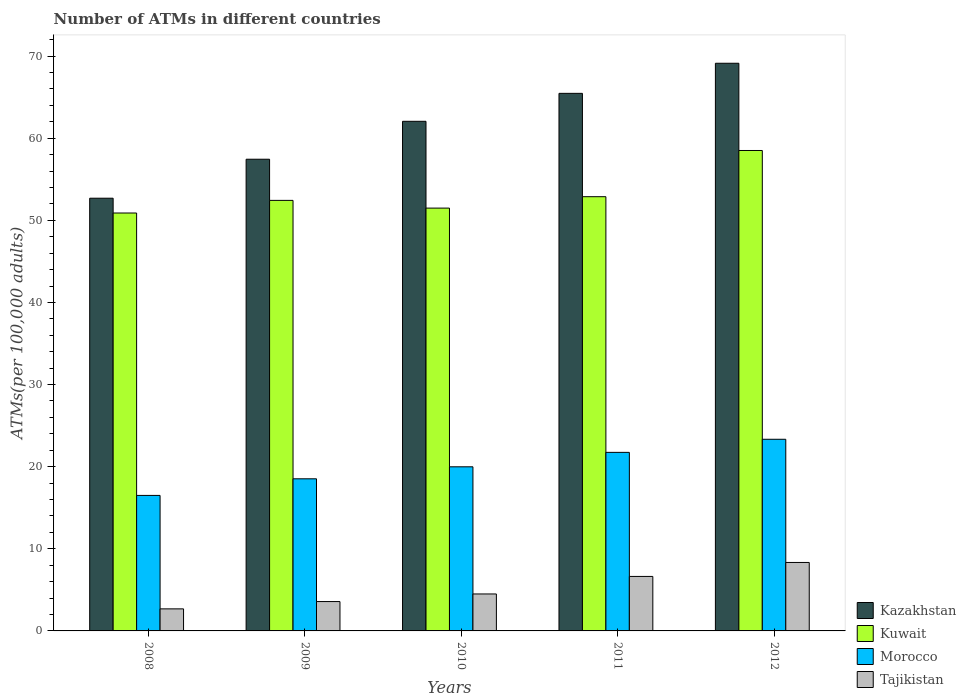How many different coloured bars are there?
Make the answer very short. 4. How many groups of bars are there?
Make the answer very short. 5. Are the number of bars on each tick of the X-axis equal?
Your answer should be very brief. Yes. How many bars are there on the 3rd tick from the left?
Your response must be concise. 4. How many bars are there on the 4th tick from the right?
Your response must be concise. 4. What is the label of the 4th group of bars from the left?
Your response must be concise. 2011. What is the number of ATMs in Kuwait in 2008?
Provide a short and direct response. 50.89. Across all years, what is the maximum number of ATMs in Kazakhstan?
Your response must be concise. 69.12. Across all years, what is the minimum number of ATMs in Tajikistan?
Your answer should be compact. 2.69. In which year was the number of ATMs in Kuwait maximum?
Offer a terse response. 2012. In which year was the number of ATMs in Morocco minimum?
Your answer should be very brief. 2008. What is the total number of ATMs in Morocco in the graph?
Ensure brevity in your answer.  100.09. What is the difference between the number of ATMs in Kuwait in 2008 and that in 2010?
Give a very brief answer. -0.6. What is the difference between the number of ATMs in Kazakhstan in 2011 and the number of ATMs in Kuwait in 2012?
Your response must be concise. 6.96. What is the average number of ATMs in Kazakhstan per year?
Keep it short and to the point. 61.35. In the year 2012, what is the difference between the number of ATMs in Kazakhstan and number of ATMs in Tajikistan?
Your answer should be very brief. 60.79. In how many years, is the number of ATMs in Tajikistan greater than 60?
Your answer should be compact. 0. What is the ratio of the number of ATMs in Kuwait in 2008 to that in 2011?
Make the answer very short. 0.96. Is the difference between the number of ATMs in Kazakhstan in 2009 and 2011 greater than the difference between the number of ATMs in Tajikistan in 2009 and 2011?
Provide a short and direct response. No. What is the difference between the highest and the second highest number of ATMs in Kuwait?
Ensure brevity in your answer.  5.63. What is the difference between the highest and the lowest number of ATMs in Morocco?
Your answer should be very brief. 6.84. Is the sum of the number of ATMs in Kazakhstan in 2008 and 2012 greater than the maximum number of ATMs in Morocco across all years?
Provide a short and direct response. Yes. Is it the case that in every year, the sum of the number of ATMs in Tajikistan and number of ATMs in Morocco is greater than the sum of number of ATMs in Kuwait and number of ATMs in Kazakhstan?
Your response must be concise. Yes. What does the 1st bar from the left in 2011 represents?
Your answer should be compact. Kazakhstan. What does the 2nd bar from the right in 2010 represents?
Make the answer very short. Morocco. How many bars are there?
Provide a short and direct response. 20. Does the graph contain any zero values?
Provide a succinct answer. No. Does the graph contain grids?
Keep it short and to the point. No. What is the title of the graph?
Keep it short and to the point. Number of ATMs in different countries. Does "Guinea" appear as one of the legend labels in the graph?
Provide a succinct answer. No. What is the label or title of the Y-axis?
Keep it short and to the point. ATMs(per 100,0 adults). What is the ATMs(per 100,000 adults) of Kazakhstan in 2008?
Make the answer very short. 52.69. What is the ATMs(per 100,000 adults) in Kuwait in 2008?
Your answer should be very brief. 50.89. What is the ATMs(per 100,000 adults) of Morocco in 2008?
Your answer should be very brief. 16.5. What is the ATMs(per 100,000 adults) in Tajikistan in 2008?
Give a very brief answer. 2.69. What is the ATMs(per 100,000 adults) in Kazakhstan in 2009?
Give a very brief answer. 57.44. What is the ATMs(per 100,000 adults) in Kuwait in 2009?
Your answer should be compact. 52.43. What is the ATMs(per 100,000 adults) of Morocco in 2009?
Offer a very short reply. 18.52. What is the ATMs(per 100,000 adults) in Tajikistan in 2009?
Your response must be concise. 3.58. What is the ATMs(per 100,000 adults) in Kazakhstan in 2010?
Make the answer very short. 62.05. What is the ATMs(per 100,000 adults) in Kuwait in 2010?
Your response must be concise. 51.49. What is the ATMs(per 100,000 adults) in Morocco in 2010?
Make the answer very short. 19.98. What is the ATMs(per 100,000 adults) in Tajikistan in 2010?
Keep it short and to the point. 4.5. What is the ATMs(per 100,000 adults) in Kazakhstan in 2011?
Provide a succinct answer. 65.46. What is the ATMs(per 100,000 adults) in Kuwait in 2011?
Make the answer very short. 52.87. What is the ATMs(per 100,000 adults) in Morocco in 2011?
Your answer should be compact. 21.74. What is the ATMs(per 100,000 adults) of Tajikistan in 2011?
Provide a short and direct response. 6.64. What is the ATMs(per 100,000 adults) in Kazakhstan in 2012?
Your response must be concise. 69.12. What is the ATMs(per 100,000 adults) of Kuwait in 2012?
Make the answer very short. 58.5. What is the ATMs(per 100,000 adults) of Morocco in 2012?
Your answer should be compact. 23.34. What is the ATMs(per 100,000 adults) in Tajikistan in 2012?
Provide a succinct answer. 8.34. Across all years, what is the maximum ATMs(per 100,000 adults) of Kazakhstan?
Provide a short and direct response. 69.12. Across all years, what is the maximum ATMs(per 100,000 adults) of Kuwait?
Provide a succinct answer. 58.5. Across all years, what is the maximum ATMs(per 100,000 adults) in Morocco?
Keep it short and to the point. 23.34. Across all years, what is the maximum ATMs(per 100,000 adults) of Tajikistan?
Keep it short and to the point. 8.34. Across all years, what is the minimum ATMs(per 100,000 adults) in Kazakhstan?
Provide a succinct answer. 52.69. Across all years, what is the minimum ATMs(per 100,000 adults) in Kuwait?
Your answer should be very brief. 50.89. Across all years, what is the minimum ATMs(per 100,000 adults) in Morocco?
Your answer should be compact. 16.5. Across all years, what is the minimum ATMs(per 100,000 adults) in Tajikistan?
Ensure brevity in your answer.  2.69. What is the total ATMs(per 100,000 adults) in Kazakhstan in the graph?
Give a very brief answer. 306.76. What is the total ATMs(per 100,000 adults) in Kuwait in the graph?
Make the answer very short. 266.18. What is the total ATMs(per 100,000 adults) in Morocco in the graph?
Offer a terse response. 100.09. What is the total ATMs(per 100,000 adults) of Tajikistan in the graph?
Give a very brief answer. 25.73. What is the difference between the ATMs(per 100,000 adults) of Kazakhstan in 2008 and that in 2009?
Make the answer very short. -4.75. What is the difference between the ATMs(per 100,000 adults) in Kuwait in 2008 and that in 2009?
Offer a terse response. -1.54. What is the difference between the ATMs(per 100,000 adults) of Morocco in 2008 and that in 2009?
Your answer should be compact. -2.02. What is the difference between the ATMs(per 100,000 adults) in Tajikistan in 2008 and that in 2009?
Provide a short and direct response. -0.89. What is the difference between the ATMs(per 100,000 adults) in Kazakhstan in 2008 and that in 2010?
Ensure brevity in your answer.  -9.36. What is the difference between the ATMs(per 100,000 adults) in Kuwait in 2008 and that in 2010?
Ensure brevity in your answer.  -0.6. What is the difference between the ATMs(per 100,000 adults) in Morocco in 2008 and that in 2010?
Provide a succinct answer. -3.48. What is the difference between the ATMs(per 100,000 adults) in Tajikistan in 2008 and that in 2010?
Make the answer very short. -1.82. What is the difference between the ATMs(per 100,000 adults) in Kazakhstan in 2008 and that in 2011?
Your response must be concise. -12.77. What is the difference between the ATMs(per 100,000 adults) of Kuwait in 2008 and that in 2011?
Offer a very short reply. -1.99. What is the difference between the ATMs(per 100,000 adults) of Morocco in 2008 and that in 2011?
Give a very brief answer. -5.24. What is the difference between the ATMs(per 100,000 adults) in Tajikistan in 2008 and that in 2011?
Ensure brevity in your answer.  -3.95. What is the difference between the ATMs(per 100,000 adults) of Kazakhstan in 2008 and that in 2012?
Ensure brevity in your answer.  -16.43. What is the difference between the ATMs(per 100,000 adults) of Kuwait in 2008 and that in 2012?
Offer a very short reply. -7.61. What is the difference between the ATMs(per 100,000 adults) of Morocco in 2008 and that in 2012?
Your answer should be very brief. -6.84. What is the difference between the ATMs(per 100,000 adults) of Tajikistan in 2008 and that in 2012?
Your answer should be very brief. -5.65. What is the difference between the ATMs(per 100,000 adults) of Kazakhstan in 2009 and that in 2010?
Offer a very short reply. -4.62. What is the difference between the ATMs(per 100,000 adults) in Kuwait in 2009 and that in 2010?
Ensure brevity in your answer.  0.94. What is the difference between the ATMs(per 100,000 adults) of Morocco in 2009 and that in 2010?
Provide a succinct answer. -1.46. What is the difference between the ATMs(per 100,000 adults) in Tajikistan in 2009 and that in 2010?
Give a very brief answer. -0.93. What is the difference between the ATMs(per 100,000 adults) of Kazakhstan in 2009 and that in 2011?
Your response must be concise. -8.02. What is the difference between the ATMs(per 100,000 adults) of Kuwait in 2009 and that in 2011?
Provide a succinct answer. -0.45. What is the difference between the ATMs(per 100,000 adults) of Morocco in 2009 and that in 2011?
Your answer should be very brief. -3.22. What is the difference between the ATMs(per 100,000 adults) of Tajikistan in 2009 and that in 2011?
Your answer should be very brief. -3.06. What is the difference between the ATMs(per 100,000 adults) of Kazakhstan in 2009 and that in 2012?
Offer a terse response. -11.69. What is the difference between the ATMs(per 100,000 adults) of Kuwait in 2009 and that in 2012?
Ensure brevity in your answer.  -6.07. What is the difference between the ATMs(per 100,000 adults) in Morocco in 2009 and that in 2012?
Keep it short and to the point. -4.81. What is the difference between the ATMs(per 100,000 adults) of Tajikistan in 2009 and that in 2012?
Your answer should be very brief. -4.76. What is the difference between the ATMs(per 100,000 adults) in Kazakhstan in 2010 and that in 2011?
Your answer should be compact. -3.4. What is the difference between the ATMs(per 100,000 adults) in Kuwait in 2010 and that in 2011?
Keep it short and to the point. -1.39. What is the difference between the ATMs(per 100,000 adults) of Morocco in 2010 and that in 2011?
Provide a short and direct response. -1.76. What is the difference between the ATMs(per 100,000 adults) in Tajikistan in 2010 and that in 2011?
Offer a very short reply. -2.13. What is the difference between the ATMs(per 100,000 adults) in Kazakhstan in 2010 and that in 2012?
Offer a terse response. -7.07. What is the difference between the ATMs(per 100,000 adults) in Kuwait in 2010 and that in 2012?
Ensure brevity in your answer.  -7.01. What is the difference between the ATMs(per 100,000 adults) in Morocco in 2010 and that in 2012?
Ensure brevity in your answer.  -3.35. What is the difference between the ATMs(per 100,000 adults) of Tajikistan in 2010 and that in 2012?
Give a very brief answer. -3.84. What is the difference between the ATMs(per 100,000 adults) in Kazakhstan in 2011 and that in 2012?
Offer a terse response. -3.66. What is the difference between the ATMs(per 100,000 adults) in Kuwait in 2011 and that in 2012?
Provide a short and direct response. -5.63. What is the difference between the ATMs(per 100,000 adults) in Morocco in 2011 and that in 2012?
Keep it short and to the point. -1.59. What is the difference between the ATMs(per 100,000 adults) in Tajikistan in 2011 and that in 2012?
Your answer should be very brief. -1.7. What is the difference between the ATMs(per 100,000 adults) in Kazakhstan in 2008 and the ATMs(per 100,000 adults) in Kuwait in 2009?
Ensure brevity in your answer.  0.27. What is the difference between the ATMs(per 100,000 adults) in Kazakhstan in 2008 and the ATMs(per 100,000 adults) in Morocco in 2009?
Keep it short and to the point. 34.17. What is the difference between the ATMs(per 100,000 adults) in Kazakhstan in 2008 and the ATMs(per 100,000 adults) in Tajikistan in 2009?
Make the answer very short. 49.12. What is the difference between the ATMs(per 100,000 adults) of Kuwait in 2008 and the ATMs(per 100,000 adults) of Morocco in 2009?
Provide a short and direct response. 32.36. What is the difference between the ATMs(per 100,000 adults) of Kuwait in 2008 and the ATMs(per 100,000 adults) of Tajikistan in 2009?
Make the answer very short. 47.31. What is the difference between the ATMs(per 100,000 adults) in Morocco in 2008 and the ATMs(per 100,000 adults) in Tajikistan in 2009?
Give a very brief answer. 12.92. What is the difference between the ATMs(per 100,000 adults) in Kazakhstan in 2008 and the ATMs(per 100,000 adults) in Kuwait in 2010?
Give a very brief answer. 1.2. What is the difference between the ATMs(per 100,000 adults) in Kazakhstan in 2008 and the ATMs(per 100,000 adults) in Morocco in 2010?
Your response must be concise. 32.71. What is the difference between the ATMs(per 100,000 adults) of Kazakhstan in 2008 and the ATMs(per 100,000 adults) of Tajikistan in 2010?
Your response must be concise. 48.19. What is the difference between the ATMs(per 100,000 adults) in Kuwait in 2008 and the ATMs(per 100,000 adults) in Morocco in 2010?
Provide a short and direct response. 30.9. What is the difference between the ATMs(per 100,000 adults) of Kuwait in 2008 and the ATMs(per 100,000 adults) of Tajikistan in 2010?
Offer a terse response. 46.39. What is the difference between the ATMs(per 100,000 adults) of Morocco in 2008 and the ATMs(per 100,000 adults) of Tajikistan in 2010?
Offer a terse response. 12. What is the difference between the ATMs(per 100,000 adults) of Kazakhstan in 2008 and the ATMs(per 100,000 adults) of Kuwait in 2011?
Offer a terse response. -0.18. What is the difference between the ATMs(per 100,000 adults) of Kazakhstan in 2008 and the ATMs(per 100,000 adults) of Morocco in 2011?
Give a very brief answer. 30.95. What is the difference between the ATMs(per 100,000 adults) in Kazakhstan in 2008 and the ATMs(per 100,000 adults) in Tajikistan in 2011?
Keep it short and to the point. 46.06. What is the difference between the ATMs(per 100,000 adults) of Kuwait in 2008 and the ATMs(per 100,000 adults) of Morocco in 2011?
Provide a succinct answer. 29.15. What is the difference between the ATMs(per 100,000 adults) in Kuwait in 2008 and the ATMs(per 100,000 adults) in Tajikistan in 2011?
Provide a succinct answer. 44.25. What is the difference between the ATMs(per 100,000 adults) of Morocco in 2008 and the ATMs(per 100,000 adults) of Tajikistan in 2011?
Your response must be concise. 9.86. What is the difference between the ATMs(per 100,000 adults) in Kazakhstan in 2008 and the ATMs(per 100,000 adults) in Kuwait in 2012?
Ensure brevity in your answer.  -5.81. What is the difference between the ATMs(per 100,000 adults) of Kazakhstan in 2008 and the ATMs(per 100,000 adults) of Morocco in 2012?
Provide a succinct answer. 29.35. What is the difference between the ATMs(per 100,000 adults) of Kazakhstan in 2008 and the ATMs(per 100,000 adults) of Tajikistan in 2012?
Provide a short and direct response. 44.35. What is the difference between the ATMs(per 100,000 adults) in Kuwait in 2008 and the ATMs(per 100,000 adults) in Morocco in 2012?
Your answer should be very brief. 27.55. What is the difference between the ATMs(per 100,000 adults) of Kuwait in 2008 and the ATMs(per 100,000 adults) of Tajikistan in 2012?
Provide a succinct answer. 42.55. What is the difference between the ATMs(per 100,000 adults) in Morocco in 2008 and the ATMs(per 100,000 adults) in Tajikistan in 2012?
Ensure brevity in your answer.  8.16. What is the difference between the ATMs(per 100,000 adults) in Kazakhstan in 2009 and the ATMs(per 100,000 adults) in Kuwait in 2010?
Offer a very short reply. 5.95. What is the difference between the ATMs(per 100,000 adults) in Kazakhstan in 2009 and the ATMs(per 100,000 adults) in Morocco in 2010?
Keep it short and to the point. 37.45. What is the difference between the ATMs(per 100,000 adults) in Kazakhstan in 2009 and the ATMs(per 100,000 adults) in Tajikistan in 2010?
Provide a short and direct response. 52.94. What is the difference between the ATMs(per 100,000 adults) in Kuwait in 2009 and the ATMs(per 100,000 adults) in Morocco in 2010?
Your answer should be compact. 32.44. What is the difference between the ATMs(per 100,000 adults) in Kuwait in 2009 and the ATMs(per 100,000 adults) in Tajikistan in 2010?
Offer a terse response. 47.93. What is the difference between the ATMs(per 100,000 adults) in Morocco in 2009 and the ATMs(per 100,000 adults) in Tajikistan in 2010?
Ensure brevity in your answer.  14.02. What is the difference between the ATMs(per 100,000 adults) of Kazakhstan in 2009 and the ATMs(per 100,000 adults) of Kuwait in 2011?
Offer a terse response. 4.56. What is the difference between the ATMs(per 100,000 adults) in Kazakhstan in 2009 and the ATMs(per 100,000 adults) in Morocco in 2011?
Your answer should be very brief. 35.7. What is the difference between the ATMs(per 100,000 adults) of Kazakhstan in 2009 and the ATMs(per 100,000 adults) of Tajikistan in 2011?
Give a very brief answer. 50.8. What is the difference between the ATMs(per 100,000 adults) in Kuwait in 2009 and the ATMs(per 100,000 adults) in Morocco in 2011?
Offer a terse response. 30.68. What is the difference between the ATMs(per 100,000 adults) in Kuwait in 2009 and the ATMs(per 100,000 adults) in Tajikistan in 2011?
Provide a short and direct response. 45.79. What is the difference between the ATMs(per 100,000 adults) of Morocco in 2009 and the ATMs(per 100,000 adults) of Tajikistan in 2011?
Offer a very short reply. 11.89. What is the difference between the ATMs(per 100,000 adults) in Kazakhstan in 2009 and the ATMs(per 100,000 adults) in Kuwait in 2012?
Give a very brief answer. -1.06. What is the difference between the ATMs(per 100,000 adults) of Kazakhstan in 2009 and the ATMs(per 100,000 adults) of Morocco in 2012?
Your response must be concise. 34.1. What is the difference between the ATMs(per 100,000 adults) of Kazakhstan in 2009 and the ATMs(per 100,000 adults) of Tajikistan in 2012?
Your response must be concise. 49.1. What is the difference between the ATMs(per 100,000 adults) in Kuwait in 2009 and the ATMs(per 100,000 adults) in Morocco in 2012?
Give a very brief answer. 29.09. What is the difference between the ATMs(per 100,000 adults) in Kuwait in 2009 and the ATMs(per 100,000 adults) in Tajikistan in 2012?
Provide a succinct answer. 44.09. What is the difference between the ATMs(per 100,000 adults) in Morocco in 2009 and the ATMs(per 100,000 adults) in Tajikistan in 2012?
Make the answer very short. 10.19. What is the difference between the ATMs(per 100,000 adults) of Kazakhstan in 2010 and the ATMs(per 100,000 adults) of Kuwait in 2011?
Your answer should be very brief. 9.18. What is the difference between the ATMs(per 100,000 adults) in Kazakhstan in 2010 and the ATMs(per 100,000 adults) in Morocco in 2011?
Make the answer very short. 40.31. What is the difference between the ATMs(per 100,000 adults) in Kazakhstan in 2010 and the ATMs(per 100,000 adults) in Tajikistan in 2011?
Give a very brief answer. 55.42. What is the difference between the ATMs(per 100,000 adults) in Kuwait in 2010 and the ATMs(per 100,000 adults) in Morocco in 2011?
Keep it short and to the point. 29.74. What is the difference between the ATMs(per 100,000 adults) in Kuwait in 2010 and the ATMs(per 100,000 adults) in Tajikistan in 2011?
Your answer should be very brief. 44.85. What is the difference between the ATMs(per 100,000 adults) of Morocco in 2010 and the ATMs(per 100,000 adults) of Tajikistan in 2011?
Your answer should be very brief. 13.35. What is the difference between the ATMs(per 100,000 adults) in Kazakhstan in 2010 and the ATMs(per 100,000 adults) in Kuwait in 2012?
Offer a very short reply. 3.55. What is the difference between the ATMs(per 100,000 adults) in Kazakhstan in 2010 and the ATMs(per 100,000 adults) in Morocco in 2012?
Provide a short and direct response. 38.72. What is the difference between the ATMs(per 100,000 adults) of Kazakhstan in 2010 and the ATMs(per 100,000 adults) of Tajikistan in 2012?
Your answer should be compact. 53.72. What is the difference between the ATMs(per 100,000 adults) of Kuwait in 2010 and the ATMs(per 100,000 adults) of Morocco in 2012?
Your answer should be very brief. 28.15. What is the difference between the ATMs(per 100,000 adults) in Kuwait in 2010 and the ATMs(per 100,000 adults) in Tajikistan in 2012?
Your response must be concise. 43.15. What is the difference between the ATMs(per 100,000 adults) of Morocco in 2010 and the ATMs(per 100,000 adults) of Tajikistan in 2012?
Your response must be concise. 11.65. What is the difference between the ATMs(per 100,000 adults) of Kazakhstan in 2011 and the ATMs(per 100,000 adults) of Kuwait in 2012?
Offer a very short reply. 6.96. What is the difference between the ATMs(per 100,000 adults) of Kazakhstan in 2011 and the ATMs(per 100,000 adults) of Morocco in 2012?
Your response must be concise. 42.12. What is the difference between the ATMs(per 100,000 adults) of Kazakhstan in 2011 and the ATMs(per 100,000 adults) of Tajikistan in 2012?
Keep it short and to the point. 57.12. What is the difference between the ATMs(per 100,000 adults) in Kuwait in 2011 and the ATMs(per 100,000 adults) in Morocco in 2012?
Your answer should be very brief. 29.54. What is the difference between the ATMs(per 100,000 adults) of Kuwait in 2011 and the ATMs(per 100,000 adults) of Tajikistan in 2012?
Provide a short and direct response. 44.54. What is the difference between the ATMs(per 100,000 adults) of Morocco in 2011 and the ATMs(per 100,000 adults) of Tajikistan in 2012?
Provide a succinct answer. 13.4. What is the average ATMs(per 100,000 adults) of Kazakhstan per year?
Your answer should be very brief. 61.35. What is the average ATMs(per 100,000 adults) of Kuwait per year?
Offer a terse response. 53.24. What is the average ATMs(per 100,000 adults) of Morocco per year?
Keep it short and to the point. 20.02. What is the average ATMs(per 100,000 adults) in Tajikistan per year?
Your answer should be compact. 5.15. In the year 2008, what is the difference between the ATMs(per 100,000 adults) in Kazakhstan and ATMs(per 100,000 adults) in Kuwait?
Your answer should be very brief. 1.8. In the year 2008, what is the difference between the ATMs(per 100,000 adults) of Kazakhstan and ATMs(per 100,000 adults) of Morocco?
Provide a short and direct response. 36.19. In the year 2008, what is the difference between the ATMs(per 100,000 adults) in Kazakhstan and ATMs(per 100,000 adults) in Tajikistan?
Your answer should be very brief. 50.01. In the year 2008, what is the difference between the ATMs(per 100,000 adults) in Kuwait and ATMs(per 100,000 adults) in Morocco?
Ensure brevity in your answer.  34.39. In the year 2008, what is the difference between the ATMs(per 100,000 adults) of Kuwait and ATMs(per 100,000 adults) of Tajikistan?
Your response must be concise. 48.2. In the year 2008, what is the difference between the ATMs(per 100,000 adults) in Morocco and ATMs(per 100,000 adults) in Tajikistan?
Keep it short and to the point. 13.81. In the year 2009, what is the difference between the ATMs(per 100,000 adults) of Kazakhstan and ATMs(per 100,000 adults) of Kuwait?
Offer a terse response. 5.01. In the year 2009, what is the difference between the ATMs(per 100,000 adults) in Kazakhstan and ATMs(per 100,000 adults) in Morocco?
Make the answer very short. 38.91. In the year 2009, what is the difference between the ATMs(per 100,000 adults) in Kazakhstan and ATMs(per 100,000 adults) in Tajikistan?
Offer a terse response. 53.86. In the year 2009, what is the difference between the ATMs(per 100,000 adults) of Kuwait and ATMs(per 100,000 adults) of Morocco?
Give a very brief answer. 33.9. In the year 2009, what is the difference between the ATMs(per 100,000 adults) of Kuwait and ATMs(per 100,000 adults) of Tajikistan?
Your answer should be compact. 48.85. In the year 2009, what is the difference between the ATMs(per 100,000 adults) of Morocco and ATMs(per 100,000 adults) of Tajikistan?
Give a very brief answer. 14.95. In the year 2010, what is the difference between the ATMs(per 100,000 adults) in Kazakhstan and ATMs(per 100,000 adults) in Kuwait?
Your answer should be compact. 10.57. In the year 2010, what is the difference between the ATMs(per 100,000 adults) in Kazakhstan and ATMs(per 100,000 adults) in Morocco?
Give a very brief answer. 42.07. In the year 2010, what is the difference between the ATMs(per 100,000 adults) of Kazakhstan and ATMs(per 100,000 adults) of Tajikistan?
Give a very brief answer. 57.55. In the year 2010, what is the difference between the ATMs(per 100,000 adults) in Kuwait and ATMs(per 100,000 adults) in Morocco?
Your response must be concise. 31.5. In the year 2010, what is the difference between the ATMs(per 100,000 adults) of Kuwait and ATMs(per 100,000 adults) of Tajikistan?
Your answer should be compact. 46.99. In the year 2010, what is the difference between the ATMs(per 100,000 adults) in Morocco and ATMs(per 100,000 adults) in Tajikistan?
Keep it short and to the point. 15.48. In the year 2011, what is the difference between the ATMs(per 100,000 adults) of Kazakhstan and ATMs(per 100,000 adults) of Kuwait?
Your response must be concise. 12.58. In the year 2011, what is the difference between the ATMs(per 100,000 adults) in Kazakhstan and ATMs(per 100,000 adults) in Morocco?
Your answer should be very brief. 43.72. In the year 2011, what is the difference between the ATMs(per 100,000 adults) in Kazakhstan and ATMs(per 100,000 adults) in Tajikistan?
Offer a terse response. 58.82. In the year 2011, what is the difference between the ATMs(per 100,000 adults) in Kuwait and ATMs(per 100,000 adults) in Morocco?
Your response must be concise. 31.13. In the year 2011, what is the difference between the ATMs(per 100,000 adults) of Kuwait and ATMs(per 100,000 adults) of Tajikistan?
Your response must be concise. 46.24. In the year 2011, what is the difference between the ATMs(per 100,000 adults) in Morocco and ATMs(per 100,000 adults) in Tajikistan?
Offer a very short reply. 15.11. In the year 2012, what is the difference between the ATMs(per 100,000 adults) of Kazakhstan and ATMs(per 100,000 adults) of Kuwait?
Provide a short and direct response. 10.62. In the year 2012, what is the difference between the ATMs(per 100,000 adults) of Kazakhstan and ATMs(per 100,000 adults) of Morocco?
Make the answer very short. 45.79. In the year 2012, what is the difference between the ATMs(per 100,000 adults) of Kazakhstan and ATMs(per 100,000 adults) of Tajikistan?
Keep it short and to the point. 60.79. In the year 2012, what is the difference between the ATMs(per 100,000 adults) of Kuwait and ATMs(per 100,000 adults) of Morocco?
Give a very brief answer. 35.16. In the year 2012, what is the difference between the ATMs(per 100,000 adults) in Kuwait and ATMs(per 100,000 adults) in Tajikistan?
Keep it short and to the point. 50.16. In the year 2012, what is the difference between the ATMs(per 100,000 adults) in Morocco and ATMs(per 100,000 adults) in Tajikistan?
Your answer should be compact. 15. What is the ratio of the ATMs(per 100,000 adults) of Kazakhstan in 2008 to that in 2009?
Your answer should be very brief. 0.92. What is the ratio of the ATMs(per 100,000 adults) in Kuwait in 2008 to that in 2009?
Your response must be concise. 0.97. What is the ratio of the ATMs(per 100,000 adults) of Morocco in 2008 to that in 2009?
Make the answer very short. 0.89. What is the ratio of the ATMs(per 100,000 adults) of Tajikistan in 2008 to that in 2009?
Give a very brief answer. 0.75. What is the ratio of the ATMs(per 100,000 adults) in Kazakhstan in 2008 to that in 2010?
Your answer should be very brief. 0.85. What is the ratio of the ATMs(per 100,000 adults) of Kuwait in 2008 to that in 2010?
Ensure brevity in your answer.  0.99. What is the ratio of the ATMs(per 100,000 adults) of Morocco in 2008 to that in 2010?
Keep it short and to the point. 0.83. What is the ratio of the ATMs(per 100,000 adults) in Tajikistan in 2008 to that in 2010?
Give a very brief answer. 0.6. What is the ratio of the ATMs(per 100,000 adults) in Kazakhstan in 2008 to that in 2011?
Keep it short and to the point. 0.81. What is the ratio of the ATMs(per 100,000 adults) in Kuwait in 2008 to that in 2011?
Make the answer very short. 0.96. What is the ratio of the ATMs(per 100,000 adults) in Morocco in 2008 to that in 2011?
Offer a terse response. 0.76. What is the ratio of the ATMs(per 100,000 adults) of Tajikistan in 2008 to that in 2011?
Offer a very short reply. 0.4. What is the ratio of the ATMs(per 100,000 adults) of Kazakhstan in 2008 to that in 2012?
Offer a very short reply. 0.76. What is the ratio of the ATMs(per 100,000 adults) in Kuwait in 2008 to that in 2012?
Give a very brief answer. 0.87. What is the ratio of the ATMs(per 100,000 adults) in Morocco in 2008 to that in 2012?
Provide a succinct answer. 0.71. What is the ratio of the ATMs(per 100,000 adults) in Tajikistan in 2008 to that in 2012?
Your answer should be very brief. 0.32. What is the ratio of the ATMs(per 100,000 adults) of Kazakhstan in 2009 to that in 2010?
Your answer should be compact. 0.93. What is the ratio of the ATMs(per 100,000 adults) of Kuwait in 2009 to that in 2010?
Offer a very short reply. 1.02. What is the ratio of the ATMs(per 100,000 adults) of Morocco in 2009 to that in 2010?
Offer a very short reply. 0.93. What is the ratio of the ATMs(per 100,000 adults) of Tajikistan in 2009 to that in 2010?
Offer a very short reply. 0.79. What is the ratio of the ATMs(per 100,000 adults) in Kazakhstan in 2009 to that in 2011?
Your response must be concise. 0.88. What is the ratio of the ATMs(per 100,000 adults) in Morocco in 2009 to that in 2011?
Offer a very short reply. 0.85. What is the ratio of the ATMs(per 100,000 adults) of Tajikistan in 2009 to that in 2011?
Your answer should be very brief. 0.54. What is the ratio of the ATMs(per 100,000 adults) of Kazakhstan in 2009 to that in 2012?
Keep it short and to the point. 0.83. What is the ratio of the ATMs(per 100,000 adults) in Kuwait in 2009 to that in 2012?
Your answer should be compact. 0.9. What is the ratio of the ATMs(per 100,000 adults) in Morocco in 2009 to that in 2012?
Ensure brevity in your answer.  0.79. What is the ratio of the ATMs(per 100,000 adults) in Tajikistan in 2009 to that in 2012?
Offer a very short reply. 0.43. What is the ratio of the ATMs(per 100,000 adults) in Kazakhstan in 2010 to that in 2011?
Offer a very short reply. 0.95. What is the ratio of the ATMs(per 100,000 adults) in Kuwait in 2010 to that in 2011?
Your answer should be very brief. 0.97. What is the ratio of the ATMs(per 100,000 adults) of Morocco in 2010 to that in 2011?
Your answer should be compact. 0.92. What is the ratio of the ATMs(per 100,000 adults) in Tajikistan in 2010 to that in 2011?
Make the answer very short. 0.68. What is the ratio of the ATMs(per 100,000 adults) of Kazakhstan in 2010 to that in 2012?
Make the answer very short. 0.9. What is the ratio of the ATMs(per 100,000 adults) in Kuwait in 2010 to that in 2012?
Keep it short and to the point. 0.88. What is the ratio of the ATMs(per 100,000 adults) in Morocco in 2010 to that in 2012?
Provide a succinct answer. 0.86. What is the ratio of the ATMs(per 100,000 adults) of Tajikistan in 2010 to that in 2012?
Your answer should be compact. 0.54. What is the ratio of the ATMs(per 100,000 adults) in Kazakhstan in 2011 to that in 2012?
Ensure brevity in your answer.  0.95. What is the ratio of the ATMs(per 100,000 adults) of Kuwait in 2011 to that in 2012?
Ensure brevity in your answer.  0.9. What is the ratio of the ATMs(per 100,000 adults) in Morocco in 2011 to that in 2012?
Your answer should be compact. 0.93. What is the ratio of the ATMs(per 100,000 adults) of Tajikistan in 2011 to that in 2012?
Offer a terse response. 0.8. What is the difference between the highest and the second highest ATMs(per 100,000 adults) in Kazakhstan?
Your answer should be compact. 3.66. What is the difference between the highest and the second highest ATMs(per 100,000 adults) of Kuwait?
Offer a very short reply. 5.63. What is the difference between the highest and the second highest ATMs(per 100,000 adults) in Morocco?
Offer a very short reply. 1.59. What is the difference between the highest and the second highest ATMs(per 100,000 adults) of Tajikistan?
Your response must be concise. 1.7. What is the difference between the highest and the lowest ATMs(per 100,000 adults) of Kazakhstan?
Offer a very short reply. 16.43. What is the difference between the highest and the lowest ATMs(per 100,000 adults) in Kuwait?
Offer a terse response. 7.61. What is the difference between the highest and the lowest ATMs(per 100,000 adults) of Morocco?
Keep it short and to the point. 6.84. What is the difference between the highest and the lowest ATMs(per 100,000 adults) of Tajikistan?
Give a very brief answer. 5.65. 